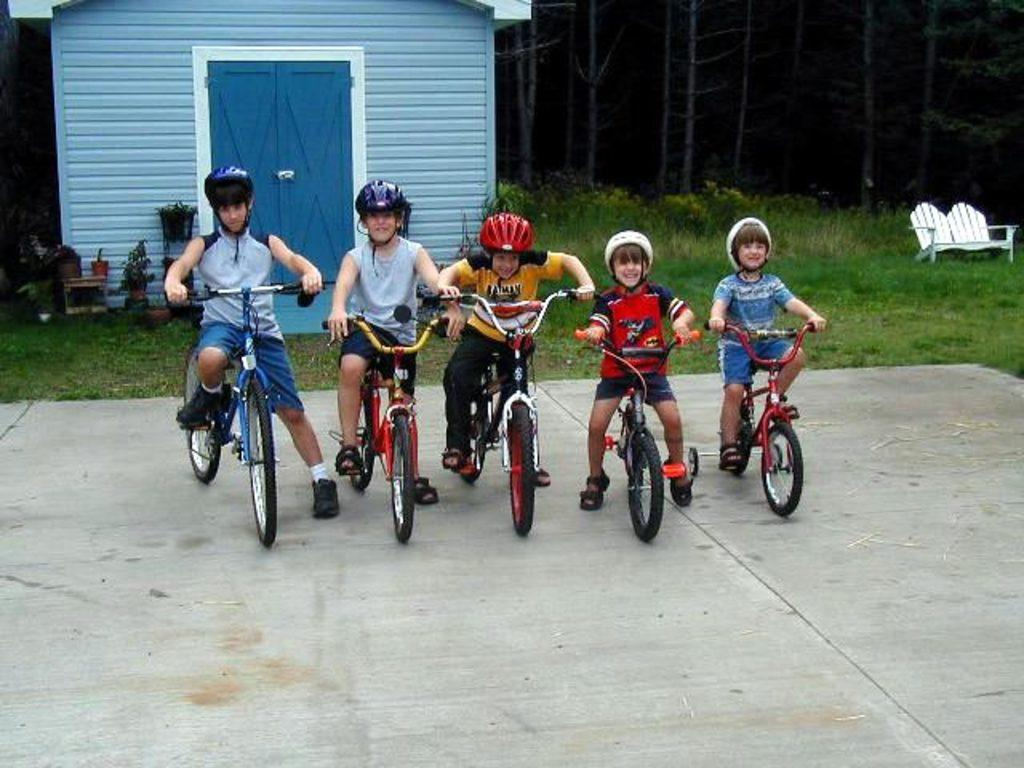What is the main subject of the image? The main subject of the image is a group of children. What are the children doing in the image? The children are sitting on a bicycle. What can be seen in the background of the image? There is a house and trees in the background of the image. How many dolls are sitting on the bicycle with the children in the image? There are no dolls present in the image; it only features a group of children sitting on a bicycle. What type of zephyr can be seen flying in the background of the image? There is no zephyr present in the image; the background only includes a house and trees. 